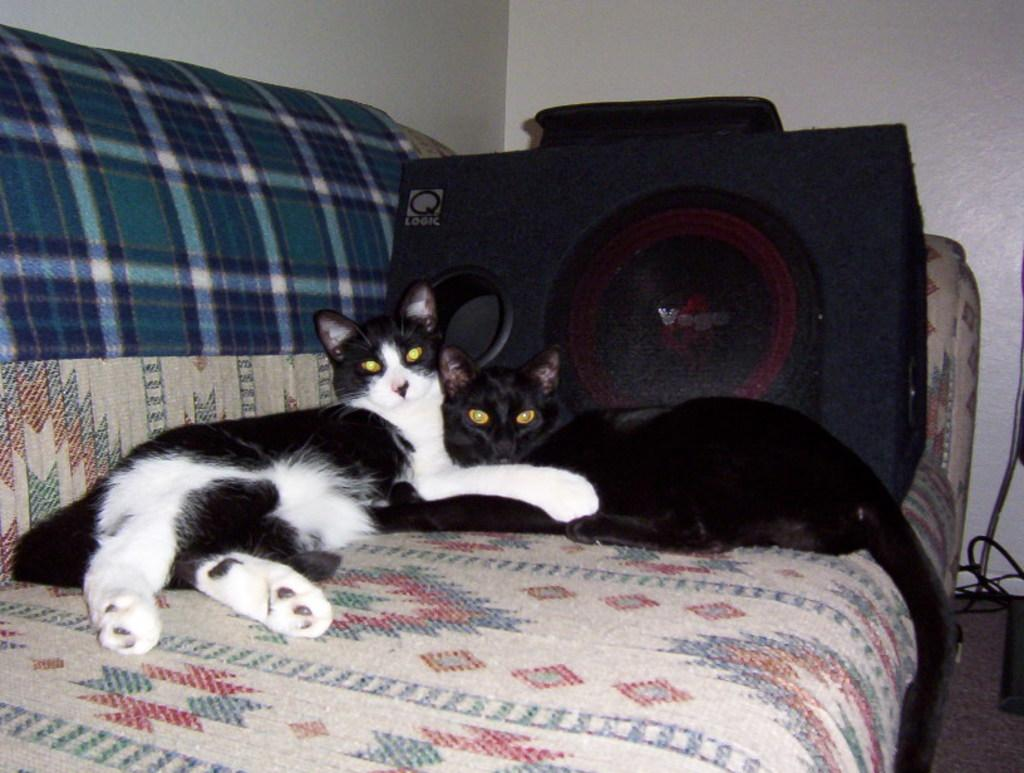How many cats are in the image? There are two cats in the image. What are the cats doing in the image? The cats are lying on a sofa. What color is the wall in the background of the image? The wall in the background of the image is white. What else can be seen in the background of the image? There are other objects visible in the background of the image. What type of sail can be seen in the image? There is no sail present in the image. Is there a tent visible in the image? No, there is no tent visible in the image. 